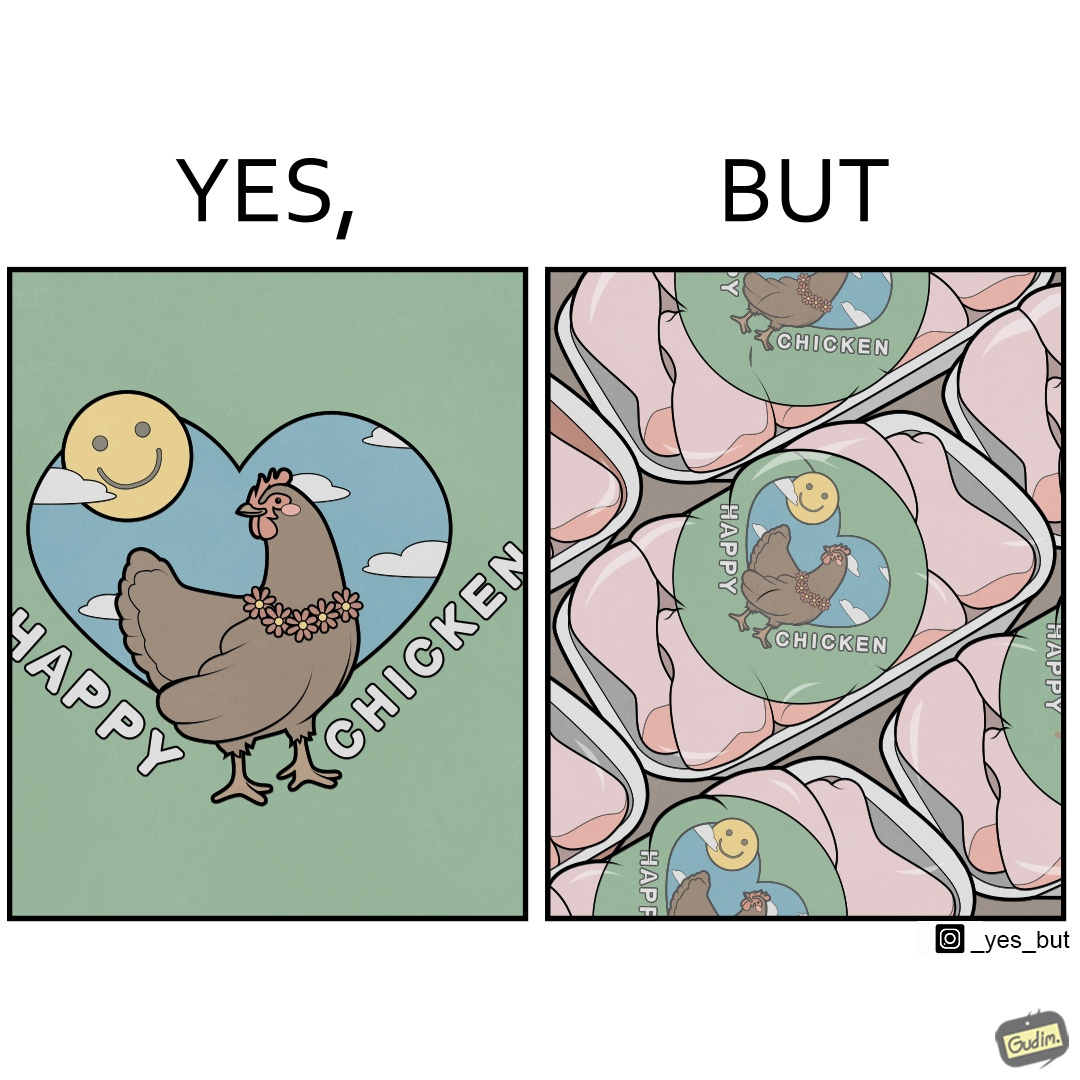Explain why this image is satirical. The image is ironic, because in the left image as in the logo it shows happy chicken but in the right image the chicken pieces are shown packed in boxes 